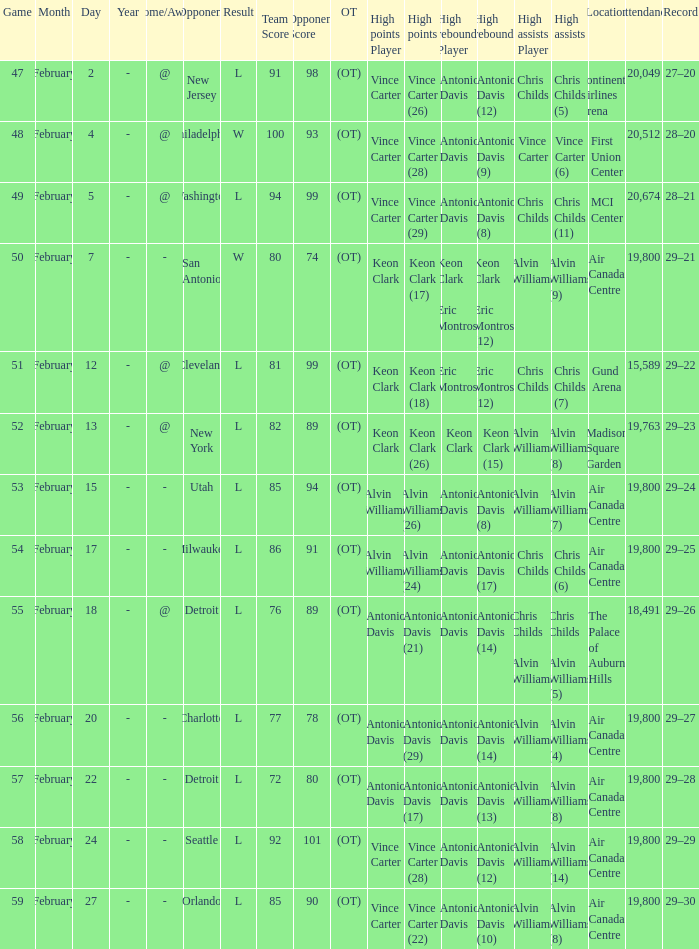What is the Team with a game of more than 56, and the score is l 85–90 (ot)? Orlando. 